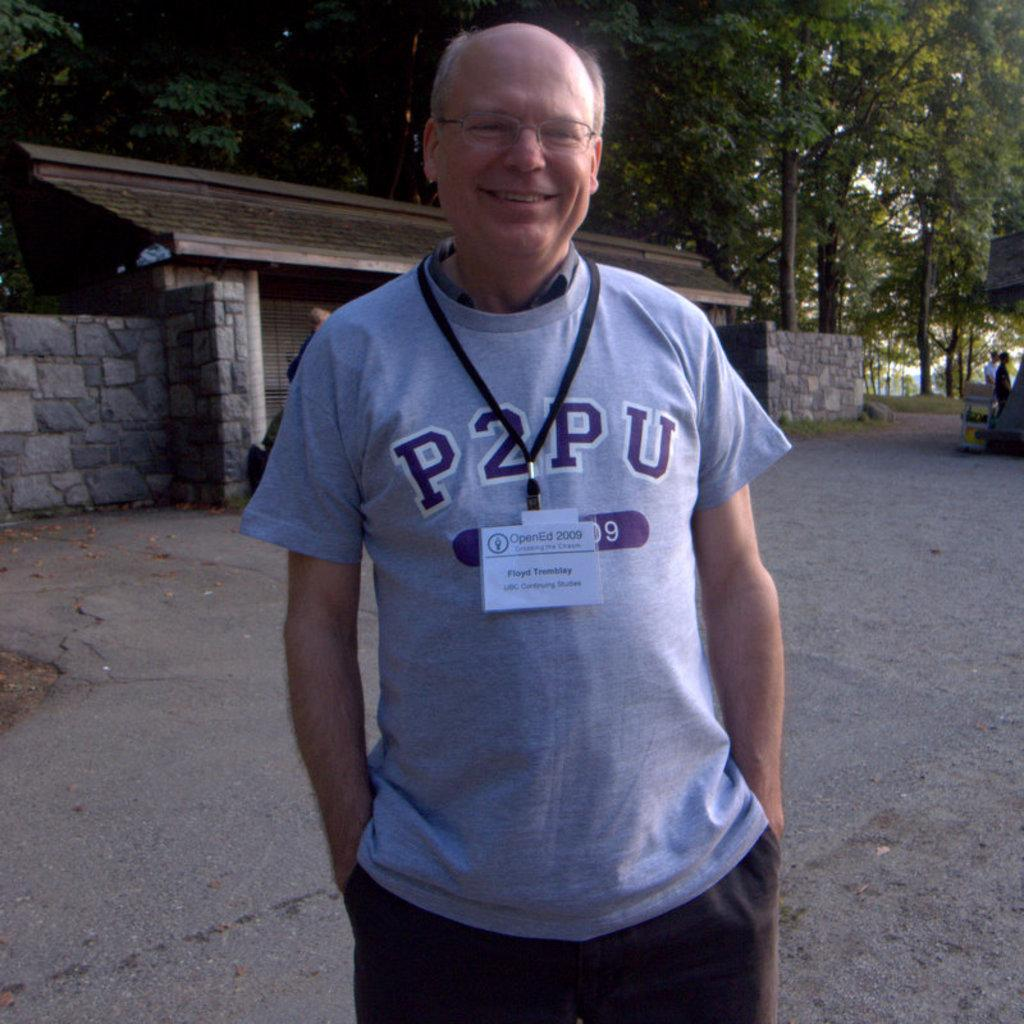Who is present in the image? There is a man in the image. What is the man wearing on his face? The man is wearing specs. What else is the man wearing? The man is wearing tags. What can be seen in the background of the image? There is a road, a brick wall, and trees in the image. Can you see any ducks swimming in the image? There are no ducks present in the image. What type of fish can be seen in the image? There are no fish present in the image. 